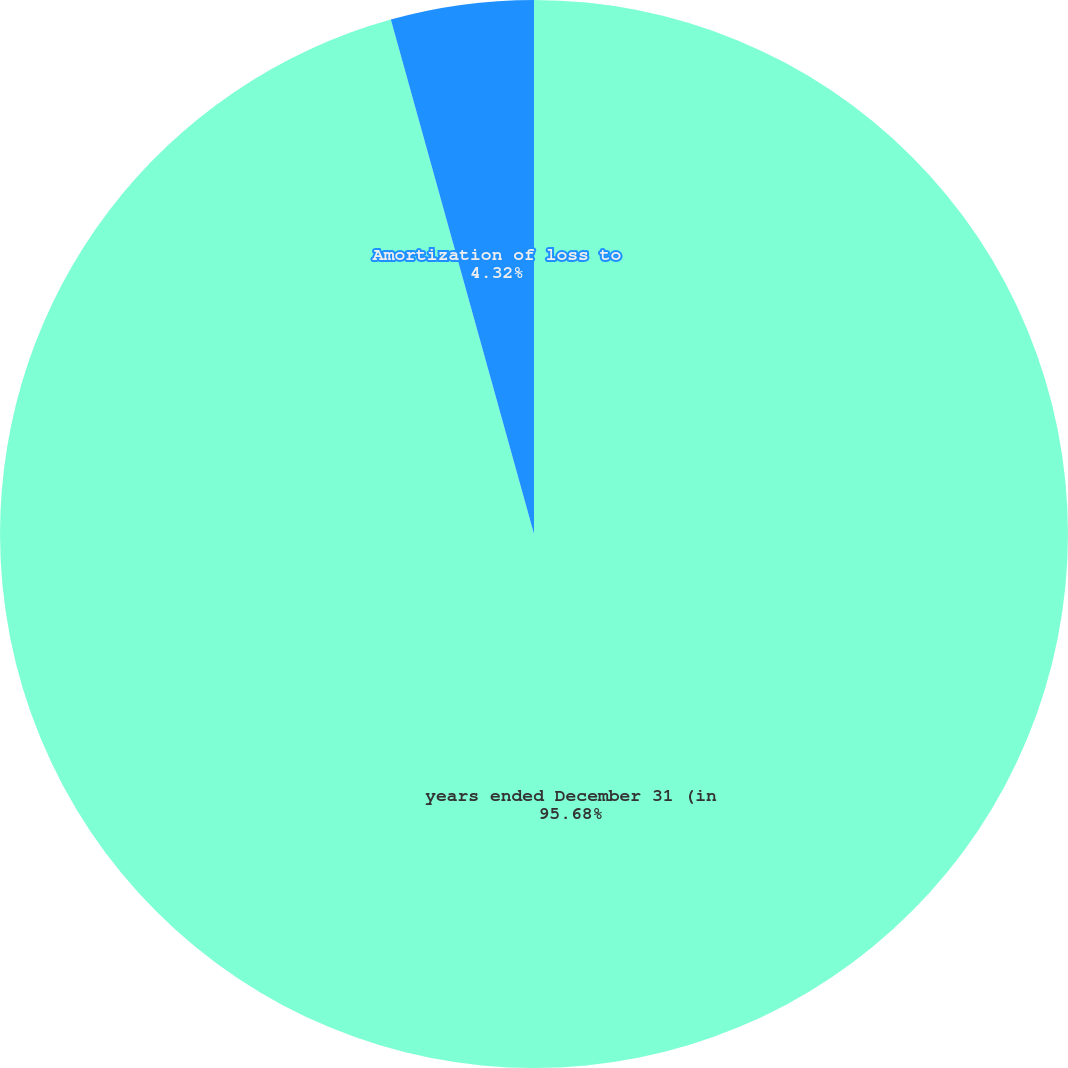<chart> <loc_0><loc_0><loc_500><loc_500><pie_chart><fcel>years ended December 31 (in<fcel>Amortization of loss to<nl><fcel>95.68%<fcel>4.32%<nl></chart> 